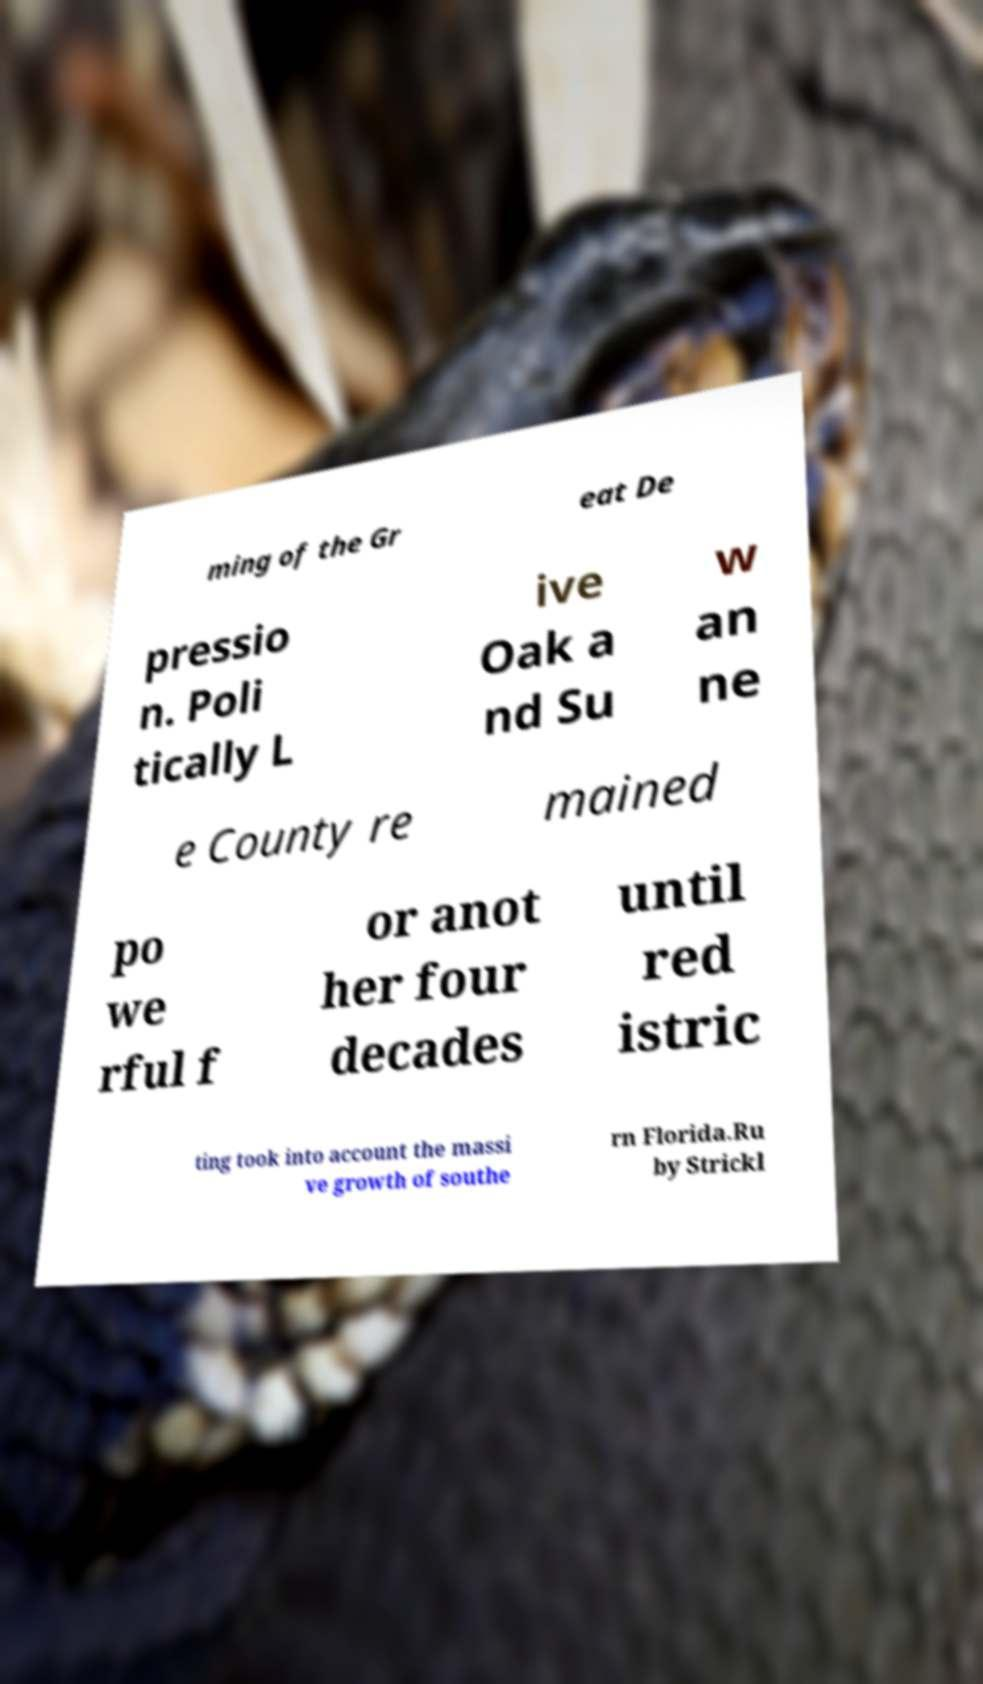Could you assist in decoding the text presented in this image and type it out clearly? ming of the Gr eat De pressio n. Poli tically L ive Oak a nd Su w an ne e County re mained po we rful f or anot her four decades until red istric ting took into account the massi ve growth of southe rn Florida.Ru by Strickl 